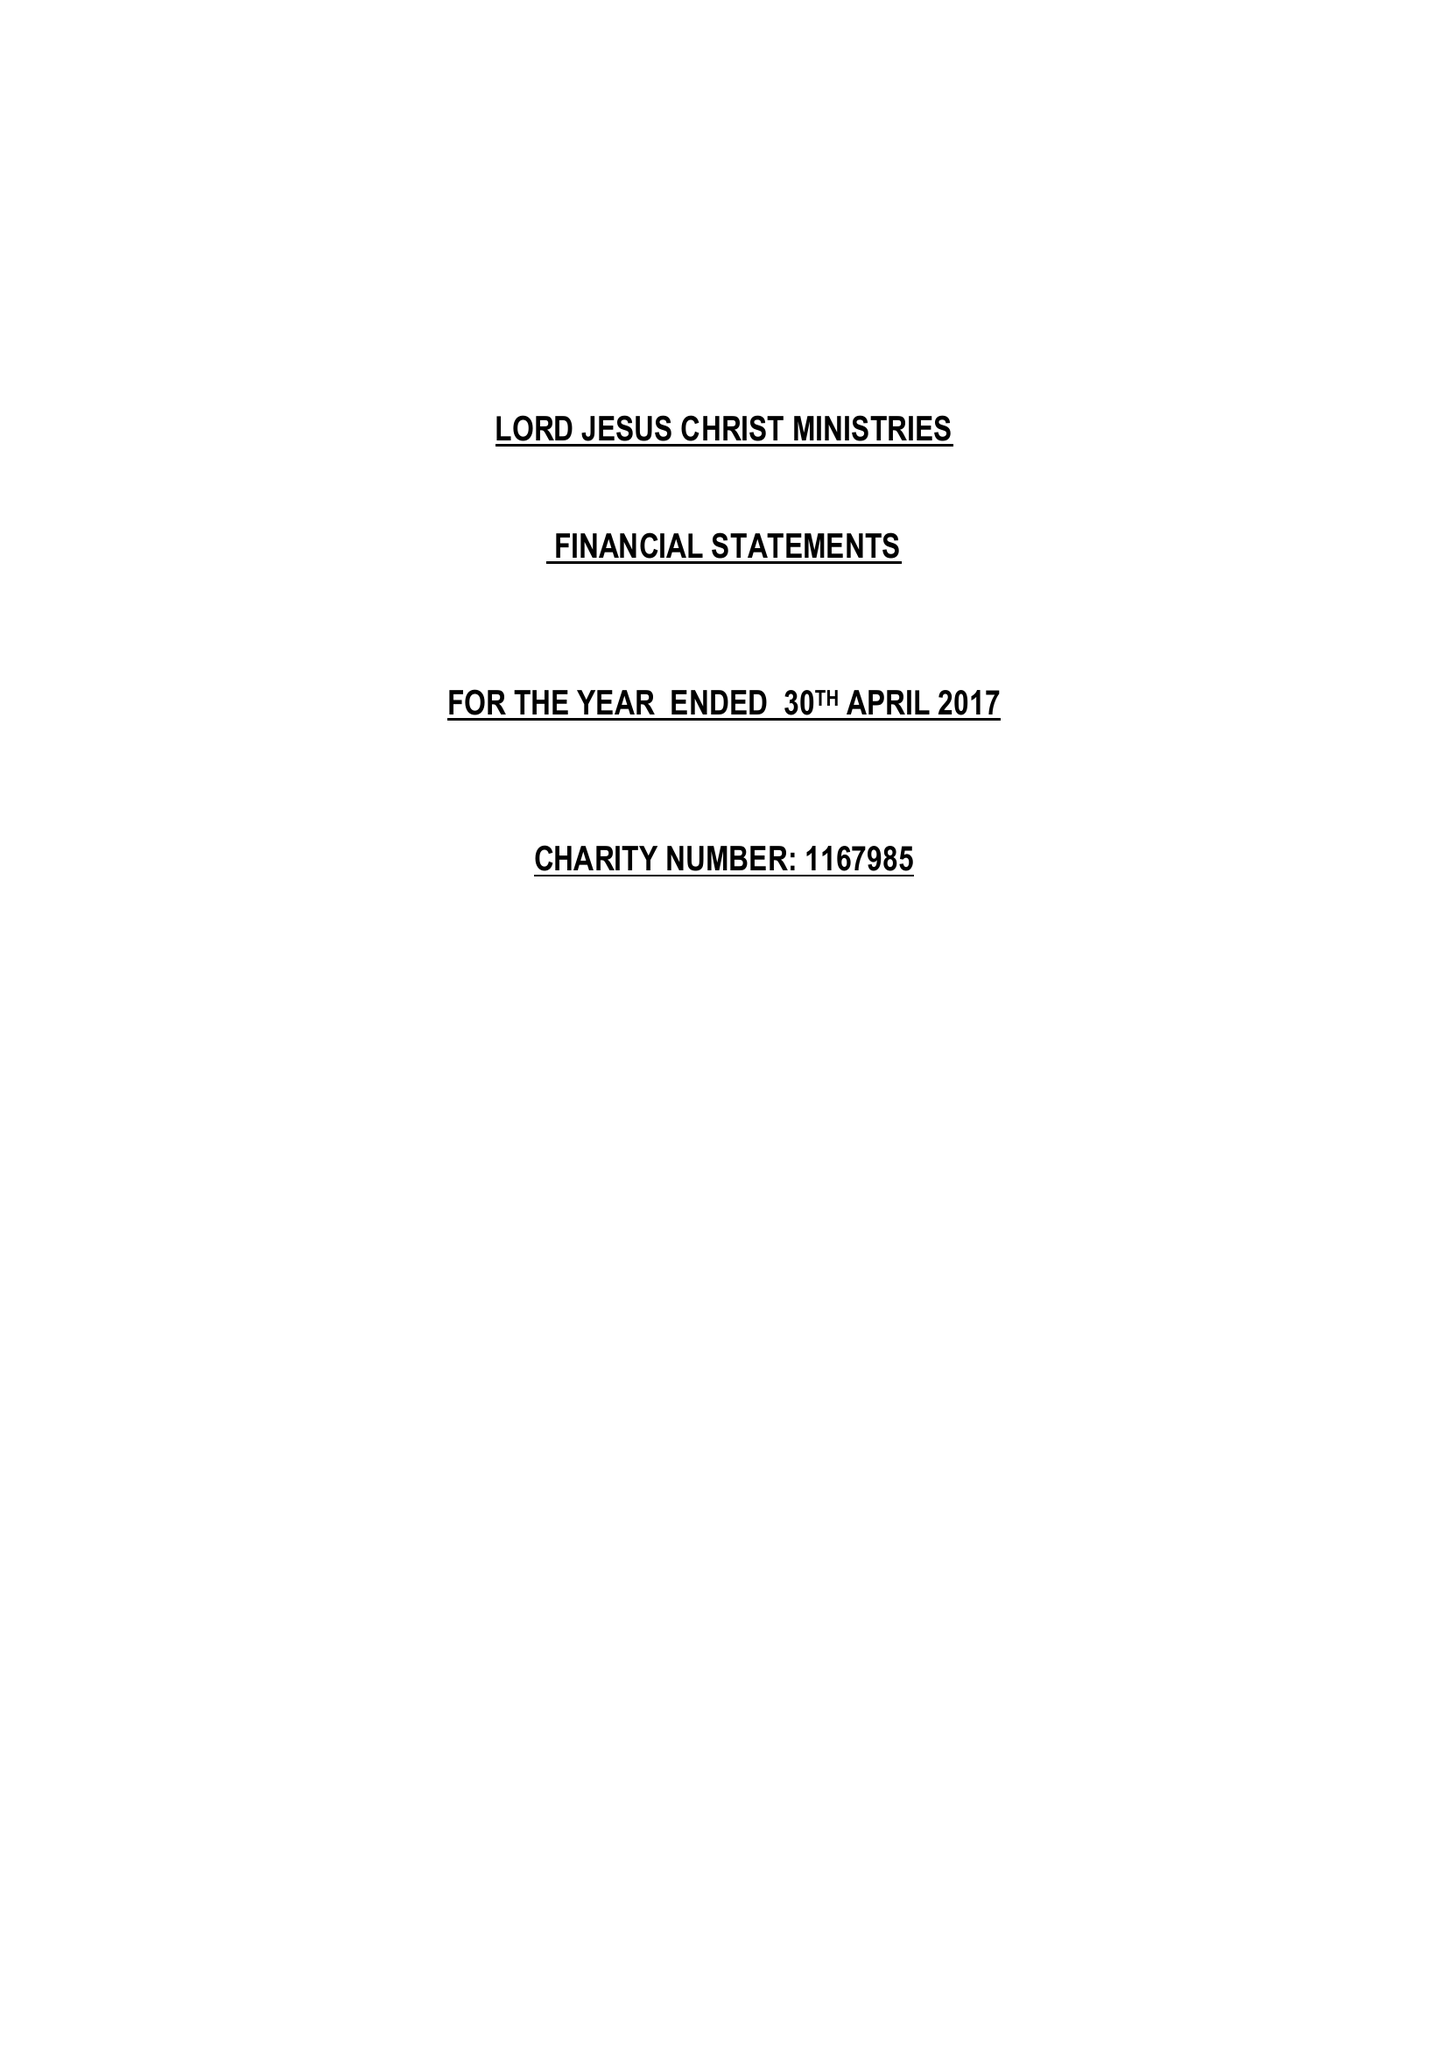What is the value for the report_date?
Answer the question using a single word or phrase. 2017-04-30 